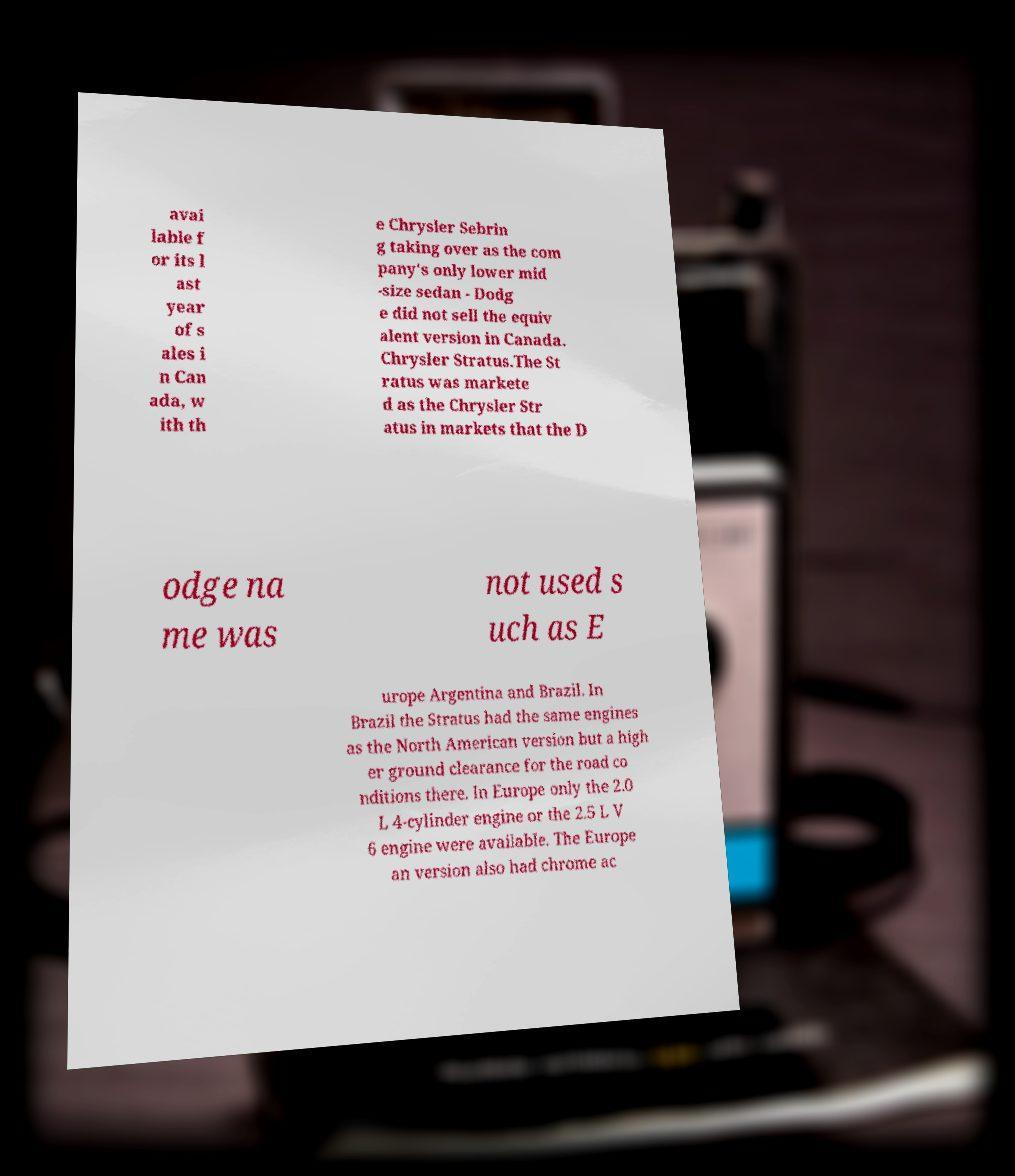Please identify and transcribe the text found in this image. avai lable f or its l ast year of s ales i n Can ada, w ith th e Chrysler Sebrin g taking over as the com pany's only lower mid -size sedan - Dodg e did not sell the equiv alent version in Canada. Chrysler Stratus.The St ratus was markete d as the Chrysler Str atus in markets that the D odge na me was not used s uch as E urope Argentina and Brazil. In Brazil the Stratus had the same engines as the North American version but a high er ground clearance for the road co nditions there. In Europe only the 2.0 L 4-cylinder engine or the 2.5 L V 6 engine were available. The Europe an version also had chrome ac 